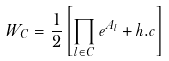<formula> <loc_0><loc_0><loc_500><loc_500>W _ { C } = \frac { 1 } { 2 } \left [ \prod _ { l \in C } e ^ { A _ { l } } + h . c \right ]</formula> 